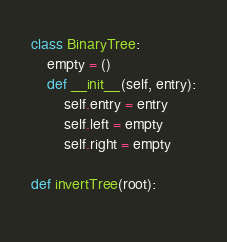Convert code to text. <code><loc_0><loc_0><loc_500><loc_500><_Python_>class BinaryTree:
    empty = ()
    def __init__(self, entry):
        self.entry = entry
        self.left = empty
        self.right = empty

def invertTree(root):
    

</code> 